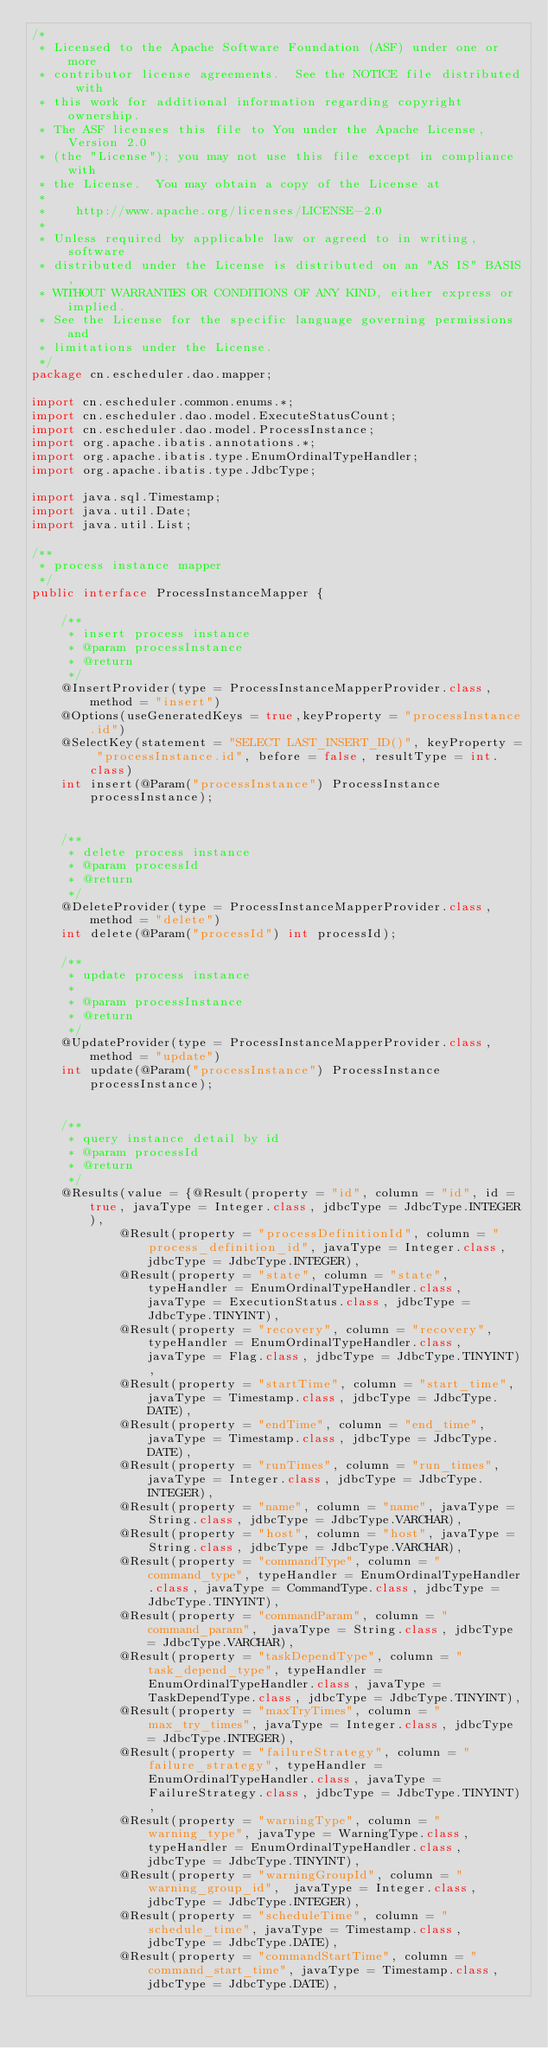Convert code to text. <code><loc_0><loc_0><loc_500><loc_500><_Java_>/*
 * Licensed to the Apache Software Foundation (ASF) under one or more
 * contributor license agreements.  See the NOTICE file distributed with
 * this work for additional information regarding copyright ownership.
 * The ASF licenses this file to You under the Apache License, Version 2.0
 * (the "License"); you may not use this file except in compliance with
 * the License.  You may obtain a copy of the License at
 *
 *    http://www.apache.org/licenses/LICENSE-2.0
 *
 * Unless required by applicable law or agreed to in writing, software
 * distributed under the License is distributed on an "AS IS" BASIS,
 * WITHOUT WARRANTIES OR CONDITIONS OF ANY KIND, either express or implied.
 * See the License for the specific language governing permissions and
 * limitations under the License.
 */
package cn.escheduler.dao.mapper;

import cn.escheduler.common.enums.*;
import cn.escheduler.dao.model.ExecuteStatusCount;
import cn.escheduler.dao.model.ProcessInstance;
import org.apache.ibatis.annotations.*;
import org.apache.ibatis.type.EnumOrdinalTypeHandler;
import org.apache.ibatis.type.JdbcType;

import java.sql.Timestamp;
import java.util.Date;
import java.util.List;

/**
 * process instance mapper
 */
public interface ProcessInstanceMapper {

    /**
     * insert process instance
     * @param processInstance
     * @return
     */
    @InsertProvider(type = ProcessInstanceMapperProvider.class, method = "insert")
    @Options(useGeneratedKeys = true,keyProperty = "processInstance.id")
    @SelectKey(statement = "SELECT LAST_INSERT_ID()", keyProperty = "processInstance.id", before = false, resultType = int.class)
    int insert(@Param("processInstance") ProcessInstance processInstance);


    /**
     * delete process instance
     * @param processId
     * @return
     */
    @DeleteProvider(type = ProcessInstanceMapperProvider.class, method = "delete")
    int delete(@Param("processId") int processId);

    /**
     * update process instance
     *
     * @param processInstance
     * @return
     */
    @UpdateProvider(type = ProcessInstanceMapperProvider.class, method = "update")
    int update(@Param("processInstance") ProcessInstance processInstance);


    /**
     * query instance detail by id
     * @param processId
     * @return
     */
    @Results(value = {@Result(property = "id", column = "id", id = true, javaType = Integer.class, jdbcType = JdbcType.INTEGER),
            @Result(property = "processDefinitionId", column = "process_definition_id", javaType = Integer.class, jdbcType = JdbcType.INTEGER),
            @Result(property = "state", column = "state", typeHandler = EnumOrdinalTypeHandler.class, javaType = ExecutionStatus.class, jdbcType = JdbcType.TINYINT),
            @Result(property = "recovery", column = "recovery",  typeHandler = EnumOrdinalTypeHandler.class, javaType = Flag.class, jdbcType = JdbcType.TINYINT),
            @Result(property = "startTime", column = "start_time", javaType = Timestamp.class, jdbcType = JdbcType.DATE),
            @Result(property = "endTime", column = "end_time", javaType = Timestamp.class, jdbcType = JdbcType.DATE),
            @Result(property = "runTimes", column = "run_times", javaType = Integer.class, jdbcType = JdbcType.INTEGER),
            @Result(property = "name", column = "name", javaType = String.class, jdbcType = JdbcType.VARCHAR),
            @Result(property = "host", column = "host", javaType = String.class, jdbcType = JdbcType.VARCHAR),
            @Result(property = "commandType", column = "command_type", typeHandler = EnumOrdinalTypeHandler.class, javaType = CommandType.class, jdbcType = JdbcType.TINYINT),
            @Result(property = "commandParam", column = "command_param",  javaType = String.class, jdbcType = JdbcType.VARCHAR),
            @Result(property = "taskDependType", column = "task_depend_type", typeHandler = EnumOrdinalTypeHandler.class, javaType = TaskDependType.class, jdbcType = JdbcType.TINYINT),
            @Result(property = "maxTryTimes", column = "max_try_times", javaType = Integer.class, jdbcType = JdbcType.INTEGER),
            @Result(property = "failureStrategy", column = "failure_strategy", typeHandler = EnumOrdinalTypeHandler.class, javaType = FailureStrategy.class, jdbcType = JdbcType.TINYINT),
            @Result(property = "warningType", column = "warning_type", javaType = WarningType.class, typeHandler = EnumOrdinalTypeHandler.class, jdbcType = JdbcType.TINYINT),
            @Result(property = "warningGroupId", column = "warning_group_id",  javaType = Integer.class, jdbcType = JdbcType.INTEGER),
            @Result(property = "scheduleTime", column = "schedule_time", javaType = Timestamp.class, jdbcType = JdbcType.DATE),
            @Result(property = "commandStartTime", column = "command_start_time", javaType = Timestamp.class, jdbcType = JdbcType.DATE),</code> 